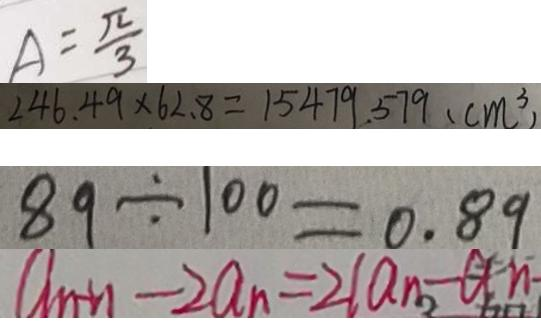Convert formula to latex. <formula><loc_0><loc_0><loc_500><loc_500>A = \frac { \pi } { 3 } 
 2 4 6 . 4 9 \times 6 2 . 8 = 1 5 4 7 9 . 5 7 9 ( c m ^ { 3 } ) 
 8 9 \div 1 0 0 = 0 . 8 9 
 a _ { n + 1 } - 2 a _ { n } = 2 ( a _ { n } - a n</formula> 